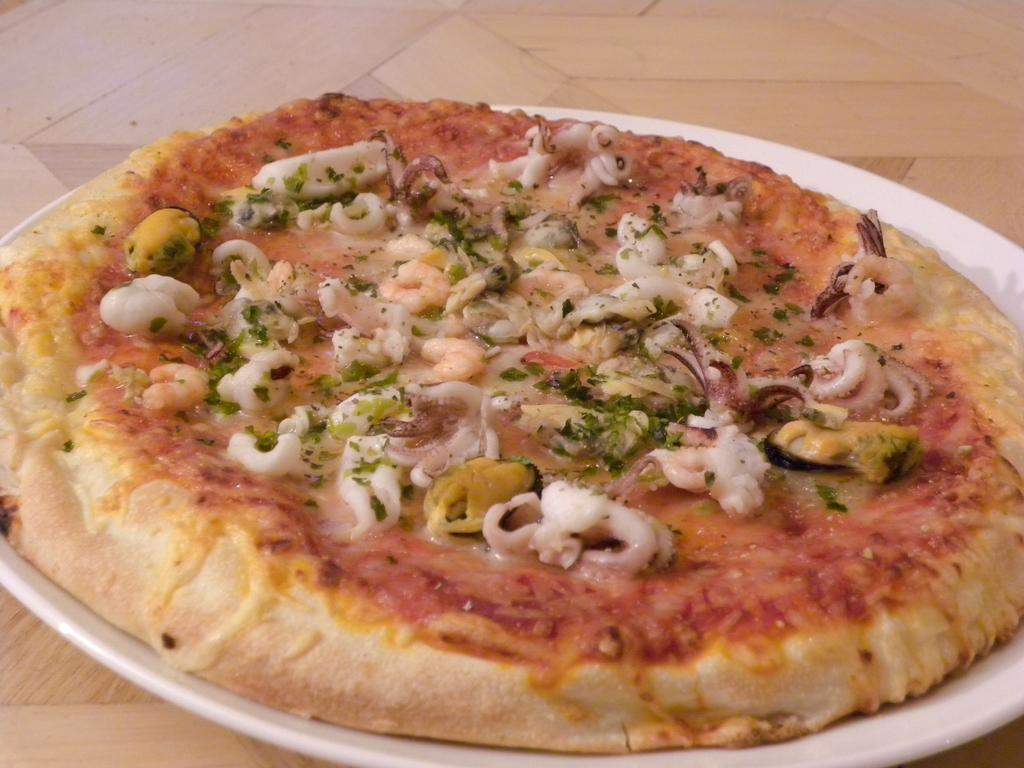What type of food is on the plate in the image? There is pizza on a plate in the image. Where is the plate with pizza located? The plate with pizza is placed on the floor. What color are the toes of the person eating the pizza in the image? There is no person or toes visible in the image; it only shows a plate with pizza placed on the floor. 